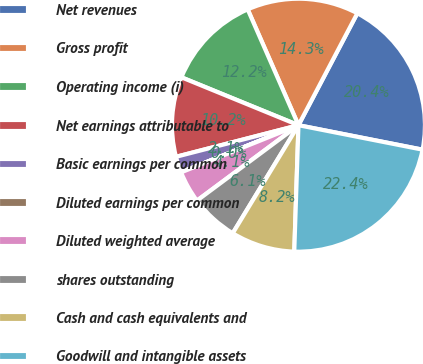Convert chart. <chart><loc_0><loc_0><loc_500><loc_500><pie_chart><fcel>Net revenues<fcel>Gross profit<fcel>Operating income (i)<fcel>Net earnings attributable to<fcel>Basic earnings per common<fcel>Diluted earnings per common<fcel>Diluted weighted average<fcel>shares outstanding<fcel>Cash and cash equivalents and<fcel>Goodwill and intangible assets<nl><fcel>20.39%<fcel>14.28%<fcel>12.24%<fcel>10.2%<fcel>2.05%<fcel>0.01%<fcel>4.09%<fcel>6.13%<fcel>8.17%<fcel>22.43%<nl></chart> 